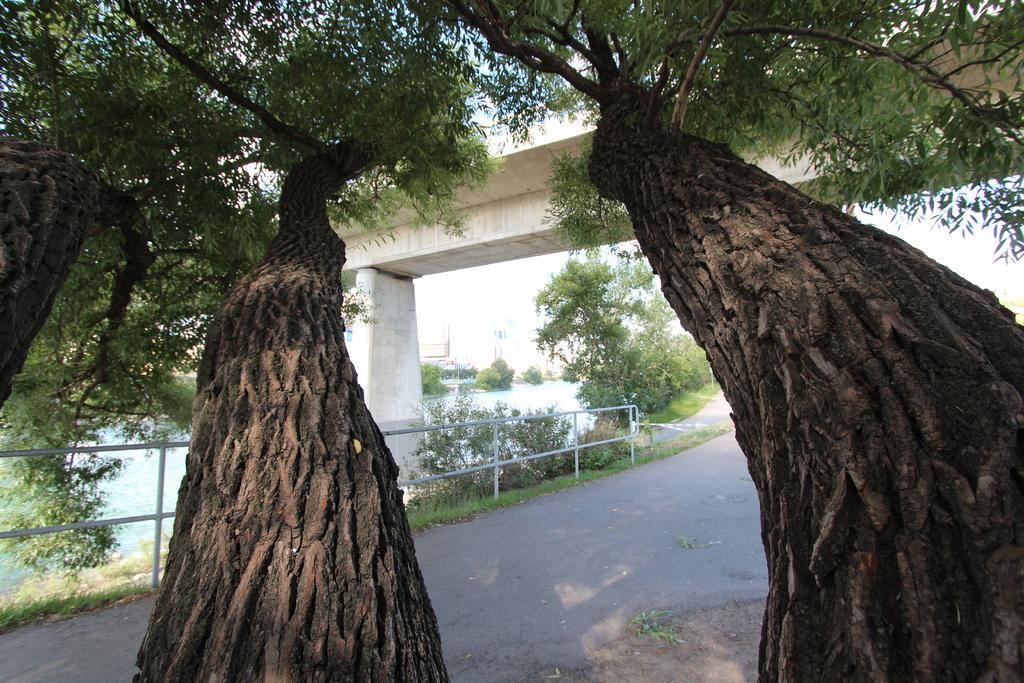What type of structure can be seen in the image? There is a bridge in the image. What natural element is visible in the image? There is water visible in the image. What type of surface is present in the image? There is a pathway in the image. What type of barrier is present in the image? There is a metal fence in the image. What type of vegetation is present in the image? There is grass, plants, and a group of trees in the image. What part of the natural environment is visible in the image? The sky is visible in the image. How many baskets are hanging from the trees in the image? There are no baskets hanging from the trees in the image. What is the feeling of the grass in the image? The feeling of the grass cannot be determined from the image, as it is a visual medium. 